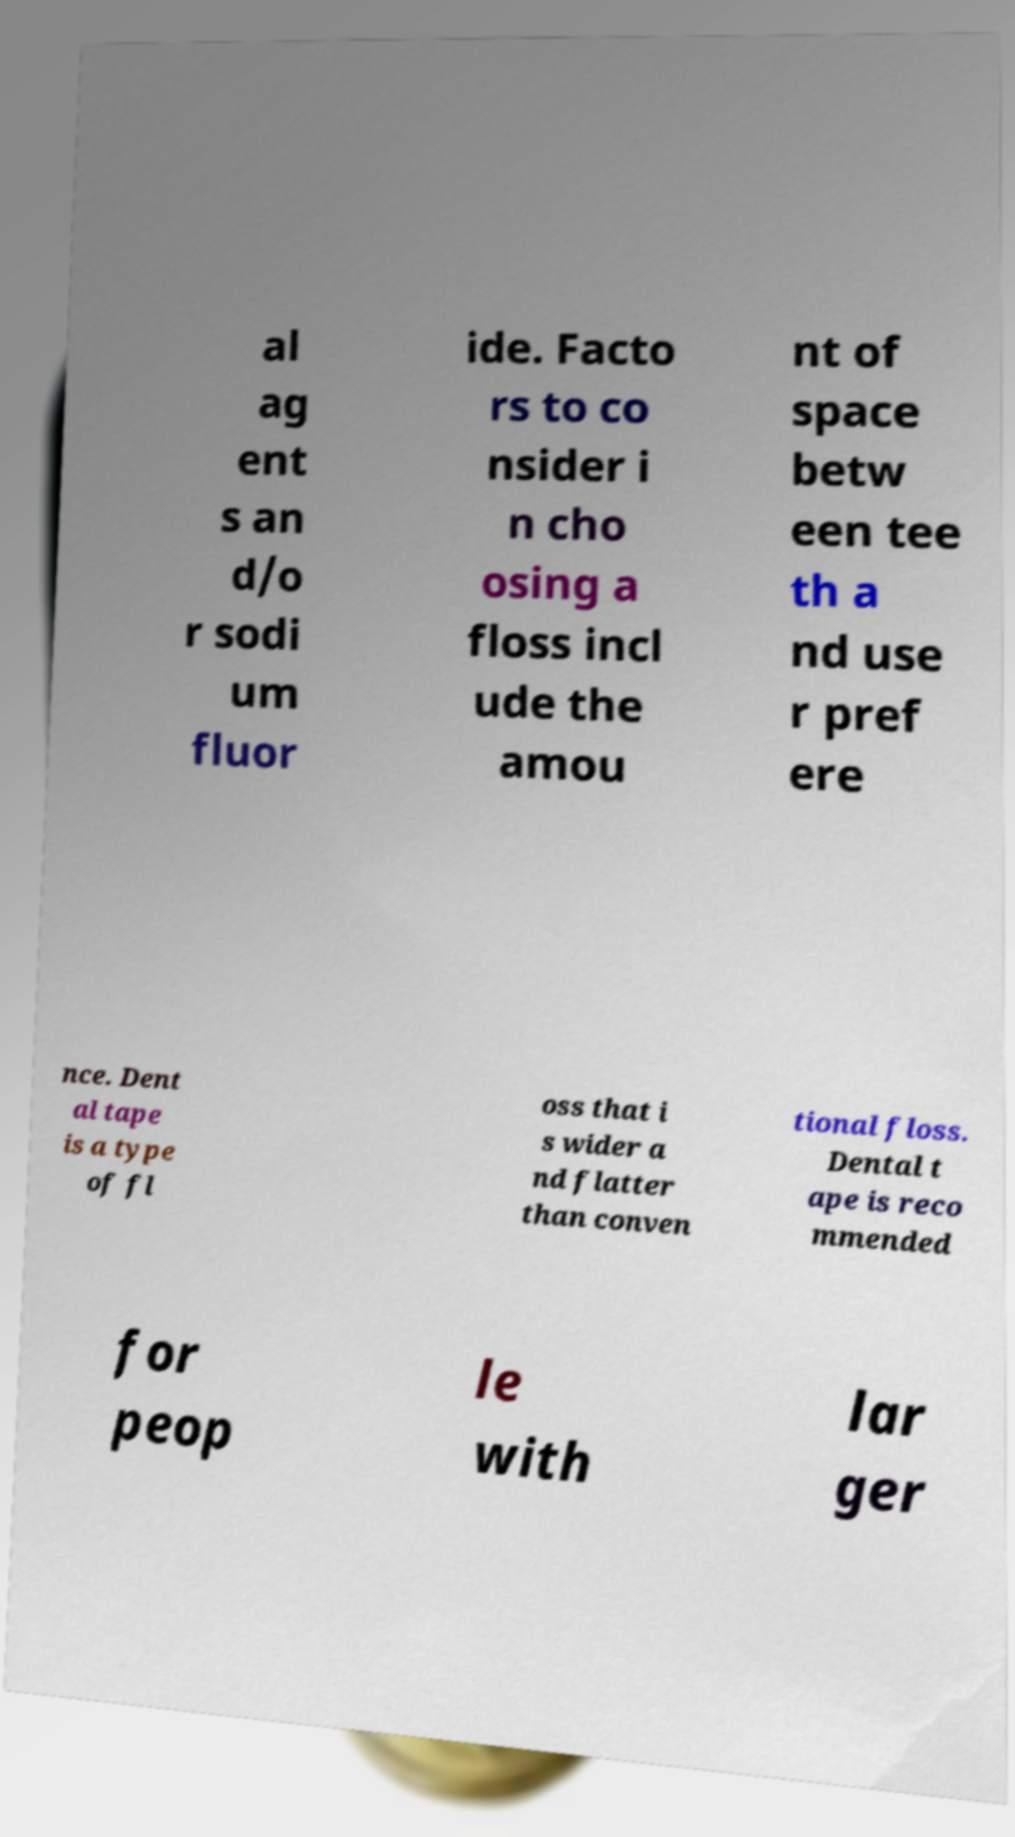There's text embedded in this image that I need extracted. Can you transcribe it verbatim? al ag ent s an d/o r sodi um fluor ide. Facto rs to co nsider i n cho osing a floss incl ude the amou nt of space betw een tee th a nd use r pref ere nce. Dent al tape is a type of fl oss that i s wider a nd flatter than conven tional floss. Dental t ape is reco mmended for peop le with lar ger 